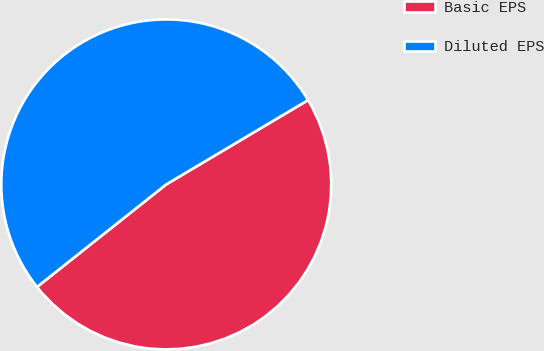Convert chart. <chart><loc_0><loc_0><loc_500><loc_500><pie_chart><fcel>Basic EPS<fcel>Diluted EPS<nl><fcel>47.86%<fcel>52.14%<nl></chart> 